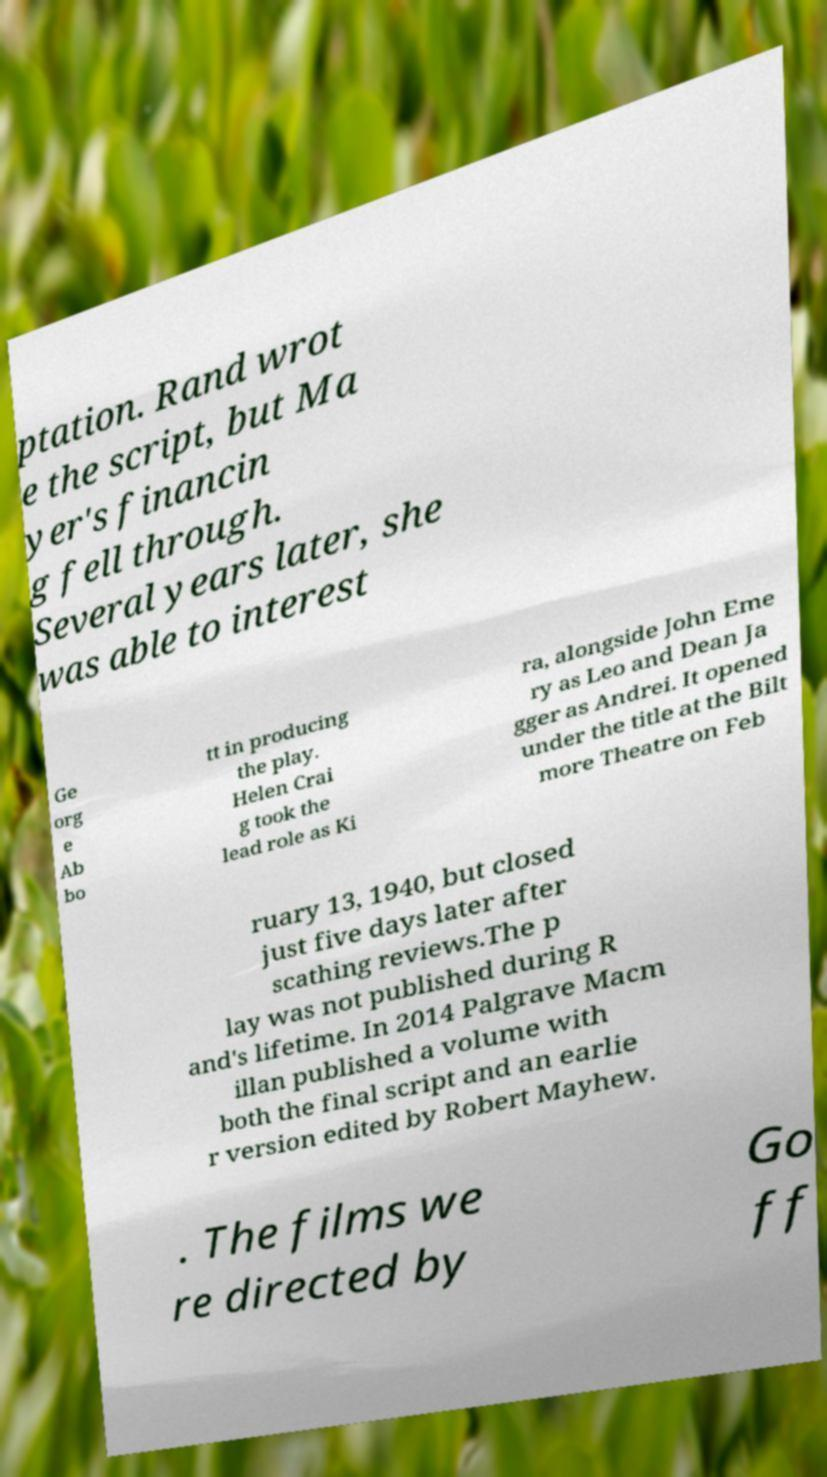Could you extract and type out the text from this image? ptation. Rand wrot e the script, but Ma yer's financin g fell through. Several years later, she was able to interest Ge org e Ab bo tt in producing the play. Helen Crai g took the lead role as Ki ra, alongside John Eme ry as Leo and Dean Ja gger as Andrei. It opened under the title at the Bilt more Theatre on Feb ruary 13, 1940, but closed just five days later after scathing reviews.The p lay was not published during R and's lifetime. In 2014 Palgrave Macm illan published a volume with both the final script and an earlie r version edited by Robert Mayhew. . The films we re directed by Go ff 